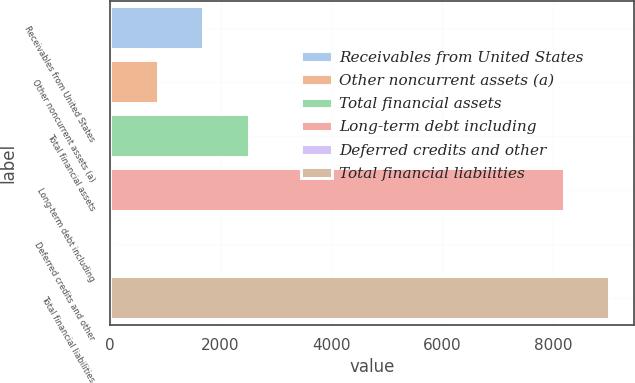Convert chart. <chart><loc_0><loc_0><loc_500><loc_500><bar_chart><fcel>Receivables from United States<fcel>Other noncurrent assets (a)<fcel>Total financial assets<fcel>Long-term debt including<fcel>Deferred credits and other<fcel>Total financial liabilities<nl><fcel>1687<fcel>868<fcel>2506<fcel>8190<fcel>49<fcel>9009<nl></chart> 